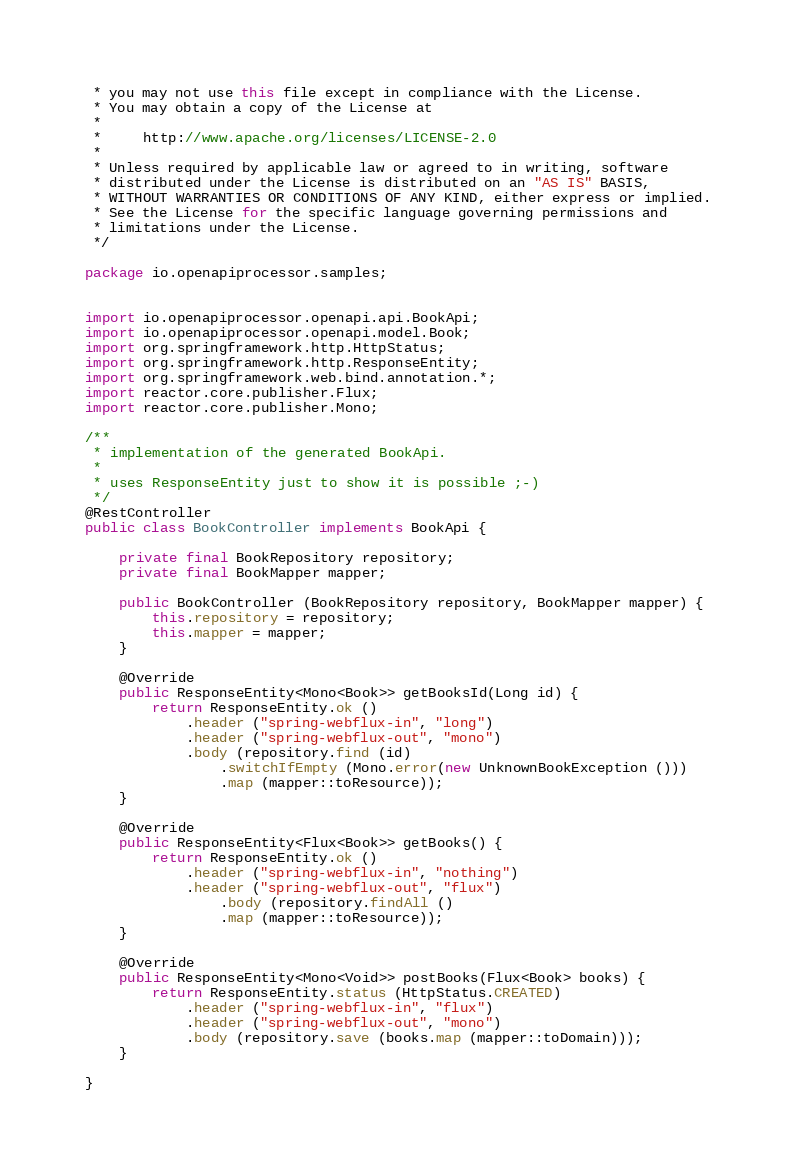<code> <loc_0><loc_0><loc_500><loc_500><_Java_> * you may not use this file except in compliance with the License.
 * You may obtain a copy of the License at
 *
 *     http://www.apache.org/licenses/LICENSE-2.0
 *
 * Unless required by applicable law or agreed to in writing, software
 * distributed under the License is distributed on an "AS IS" BASIS,
 * WITHOUT WARRANTIES OR CONDITIONS OF ANY KIND, either express or implied.
 * See the License for the specific language governing permissions and
 * limitations under the License.
 */

package io.openapiprocessor.samples;


import io.openapiprocessor.openapi.api.BookApi;
import io.openapiprocessor.openapi.model.Book;
import org.springframework.http.HttpStatus;
import org.springframework.http.ResponseEntity;
import org.springframework.web.bind.annotation.*;
import reactor.core.publisher.Flux;
import reactor.core.publisher.Mono;

/**
 * implementation of the generated BookApi.
 *
 * uses ResponseEntity just to show it is possible ;-)
 */
@RestController
public class BookController implements BookApi {

    private final BookRepository repository;
    private final BookMapper mapper;

    public BookController (BookRepository repository, BookMapper mapper) {
        this.repository = repository;
        this.mapper = mapper;
    }

    @Override
    public ResponseEntity<Mono<Book>> getBooksId(Long id) {
        return ResponseEntity.ok ()
            .header ("spring-webflux-in", "long")
            .header ("spring-webflux-out", "mono")
            .body (repository.find (id)
                .switchIfEmpty (Mono.error(new UnknownBookException ()))
                .map (mapper::toResource));
    }

    @Override
    public ResponseEntity<Flux<Book>> getBooks() {
        return ResponseEntity.ok ()
            .header ("spring-webflux-in", "nothing")
            .header ("spring-webflux-out", "flux")
                .body (repository.findAll ()
                .map (mapper::toResource));
    }

    @Override
    public ResponseEntity<Mono<Void>> postBooks(Flux<Book> books) {
        return ResponseEntity.status (HttpStatus.CREATED)
            .header ("spring-webflux-in", "flux")
            .header ("spring-webflux-out", "mono")
            .body (repository.save (books.map (mapper::toDomain)));
    }

}
</code> 